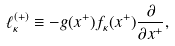<formula> <loc_0><loc_0><loc_500><loc_500>\ell _ { \kappa } ^ { ( + ) } \equiv - g ( x ^ { + } ) f _ { \kappa } ( x ^ { + } ) \frac { \partial } { \partial x ^ { + } } ,</formula> 